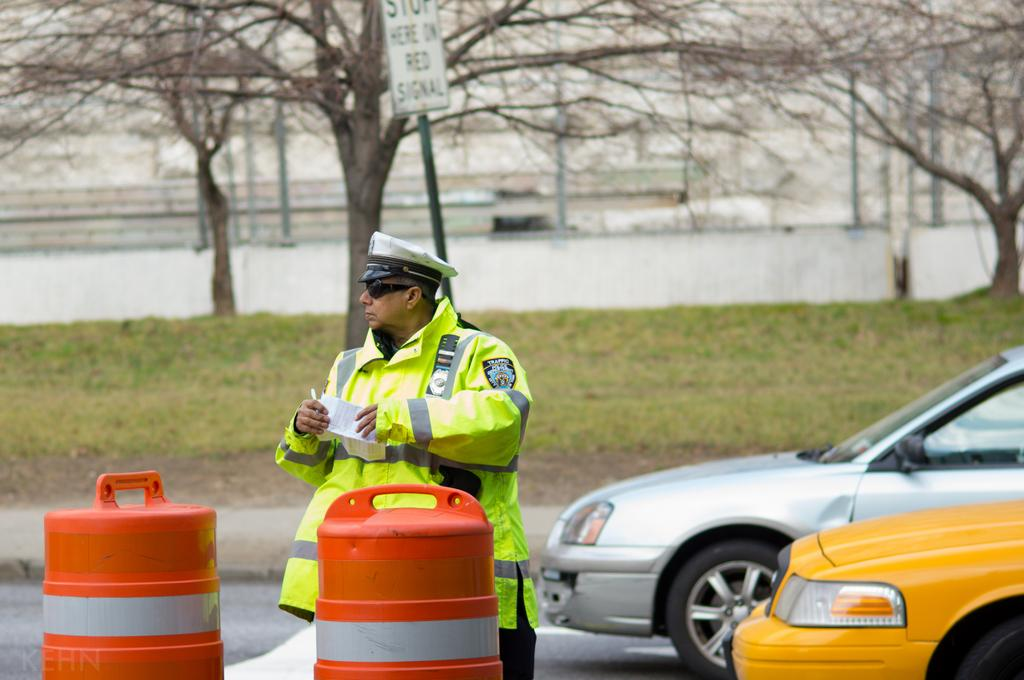<image>
Describe the image concisely. A public servant who has a badge on his sleeve that reads traffic. 